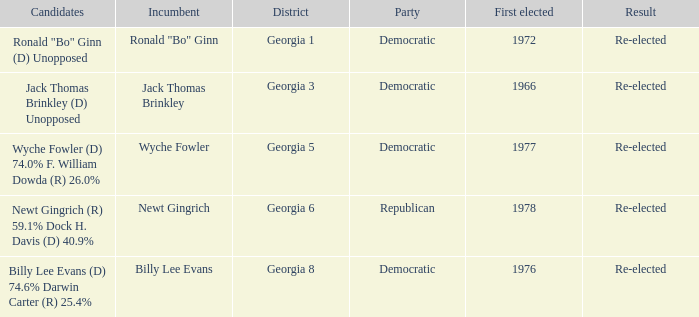How many incumbents were for district georgia 6? 1.0. 